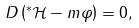Convert formula to latex. <formula><loc_0><loc_0><loc_500><loc_500>D \left ( ^ { \ast } \mathcal { H } - m \varphi \right ) = 0 ,</formula> 